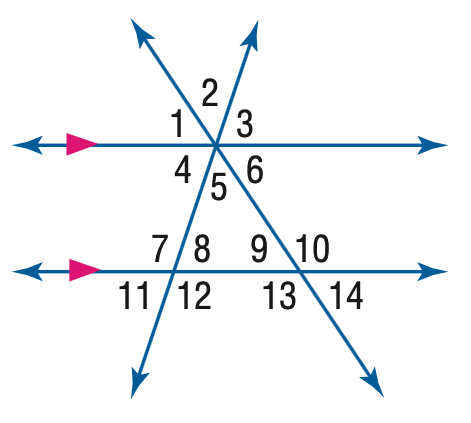Answer the mathemtical geometry problem and directly provide the correct option letter.
Question: In the figure, m \angle 11 = 62 and m \angle 14 = 38. Find the measure of \angle 12.
Choices: A: 38 B: 62 C: 118 D: 142 C 